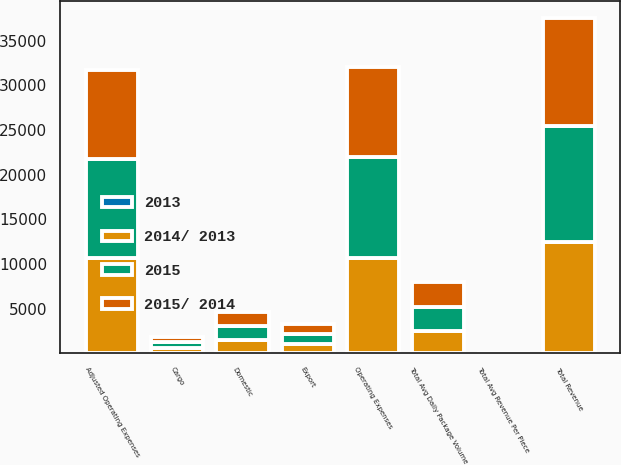Convert chart. <chart><loc_0><loc_0><loc_500><loc_500><stacked_bar_chart><ecel><fcel>Domestic<fcel>Export<fcel>Total Avg Daily Package Volume<fcel>Total Avg Revenue Per Piece<fcel>Cargo<fcel>Total Revenue<fcel>Operating Expenses<fcel>Adjusted Operating Expenses<nl><fcel>2015/ 2014<fcel>1575<fcel>1151<fcel>2726<fcel>16.63<fcel>632<fcel>12149<fcel>10012<fcel>9968<nl><fcel>2015<fcel>1579<fcel>1115<fcel>2694<fcel>18.15<fcel>618<fcel>12988<fcel>11311<fcel>11083<nl><fcel>2014/ 2013<fcel>1499<fcel>1034<fcel>2533<fcel>18.54<fcel>596<fcel>12429<fcel>10672<fcel>10633<nl><fcel>2013<fcel>0.3<fcel>3.2<fcel>1.2<fcel>8.4<fcel>2.3<fcel>6.5<fcel>11.5<fcel>10.1<nl></chart> 